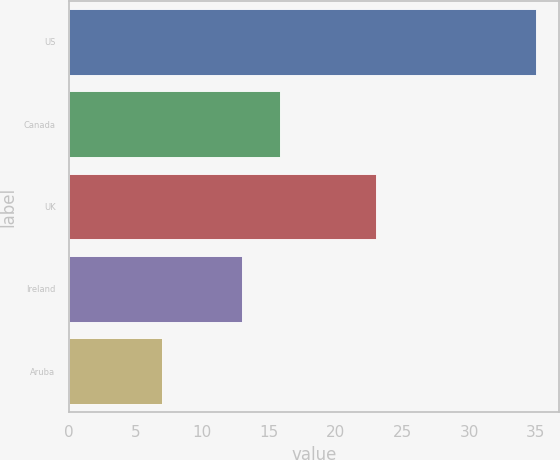<chart> <loc_0><loc_0><loc_500><loc_500><bar_chart><fcel>US<fcel>Canada<fcel>UK<fcel>Ireland<fcel>Aruba<nl><fcel>35<fcel>15.8<fcel>23<fcel>13<fcel>7<nl></chart> 